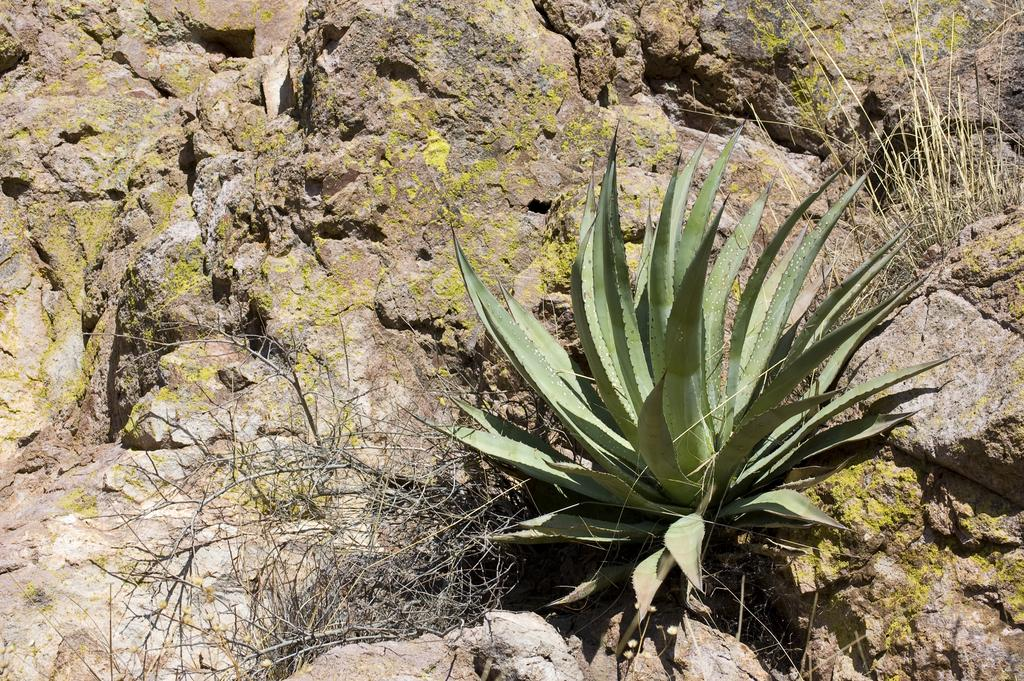What type of plant is present in the image? There is an Aloe Vera plant in the image. What is the condition of the other plants in the image? There are dried plants in the image. What can be seen on the rocks in the image? There is a formation of algae on the rocks in the image. How many friends are present in the image? There are no friends present in the image; it features plants and algae on rocks. What type of control can be seen in the image? There is no control present in the image; it features plants and algae on rocks. 